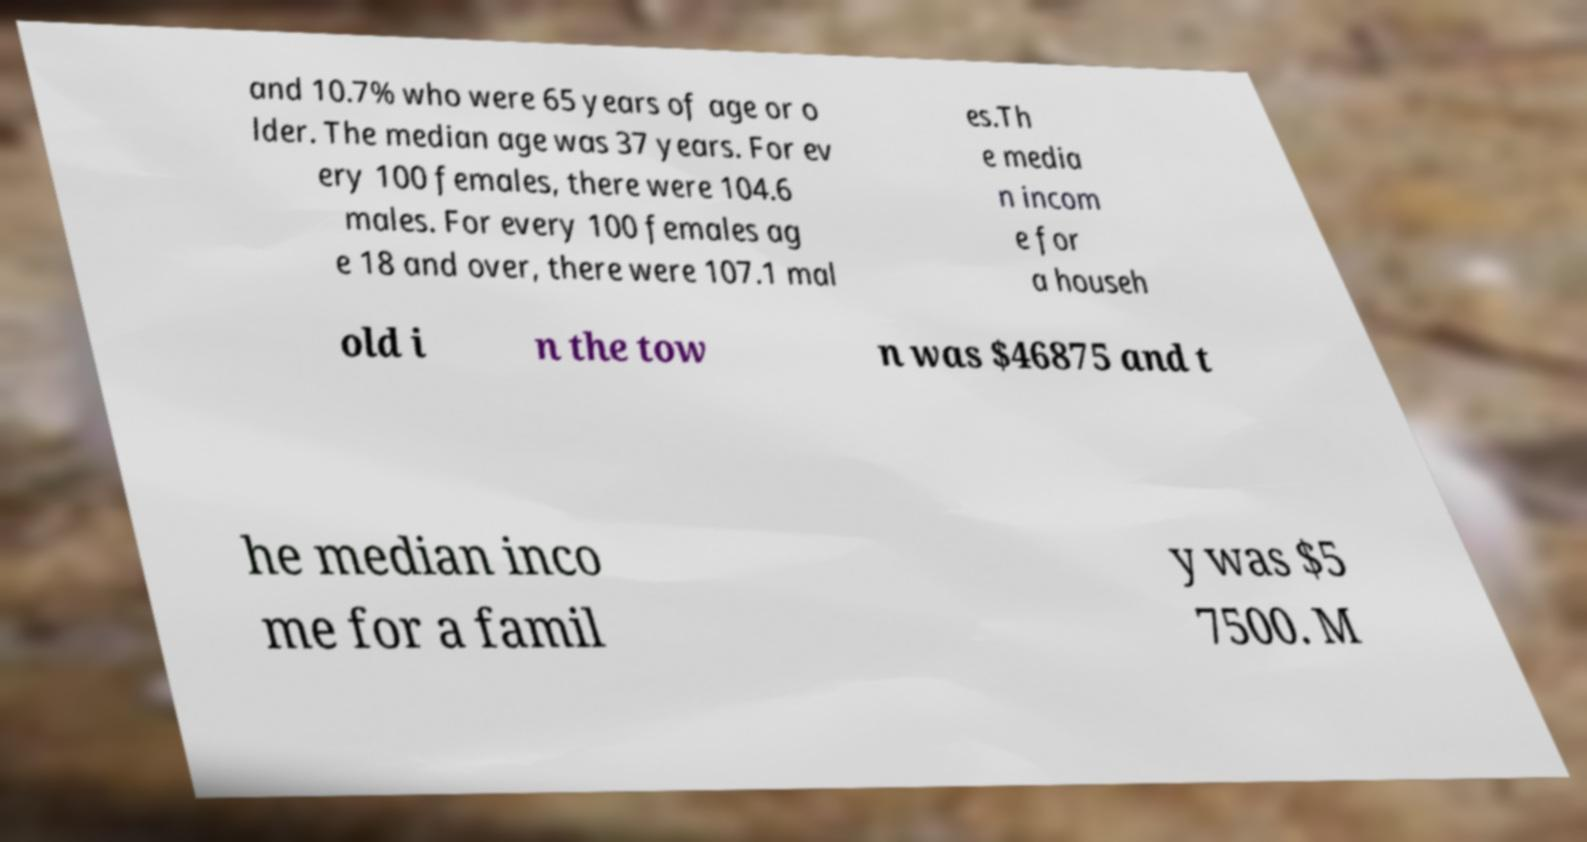Can you read and provide the text displayed in the image?This photo seems to have some interesting text. Can you extract and type it out for me? and 10.7% who were 65 years of age or o lder. The median age was 37 years. For ev ery 100 females, there were 104.6 males. For every 100 females ag e 18 and over, there were 107.1 mal es.Th e media n incom e for a househ old i n the tow n was $46875 and t he median inco me for a famil y was $5 7500. M 